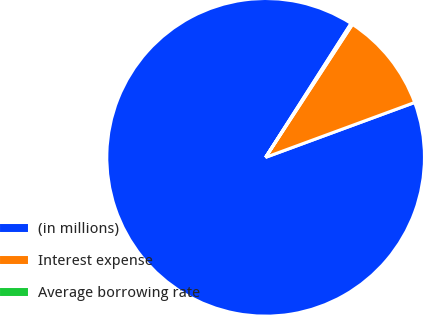<chart> <loc_0><loc_0><loc_500><loc_500><pie_chart><fcel>(in millions)<fcel>Interest expense<fcel>Average borrowing rate<nl><fcel>89.65%<fcel>10.18%<fcel>0.17%<nl></chart> 